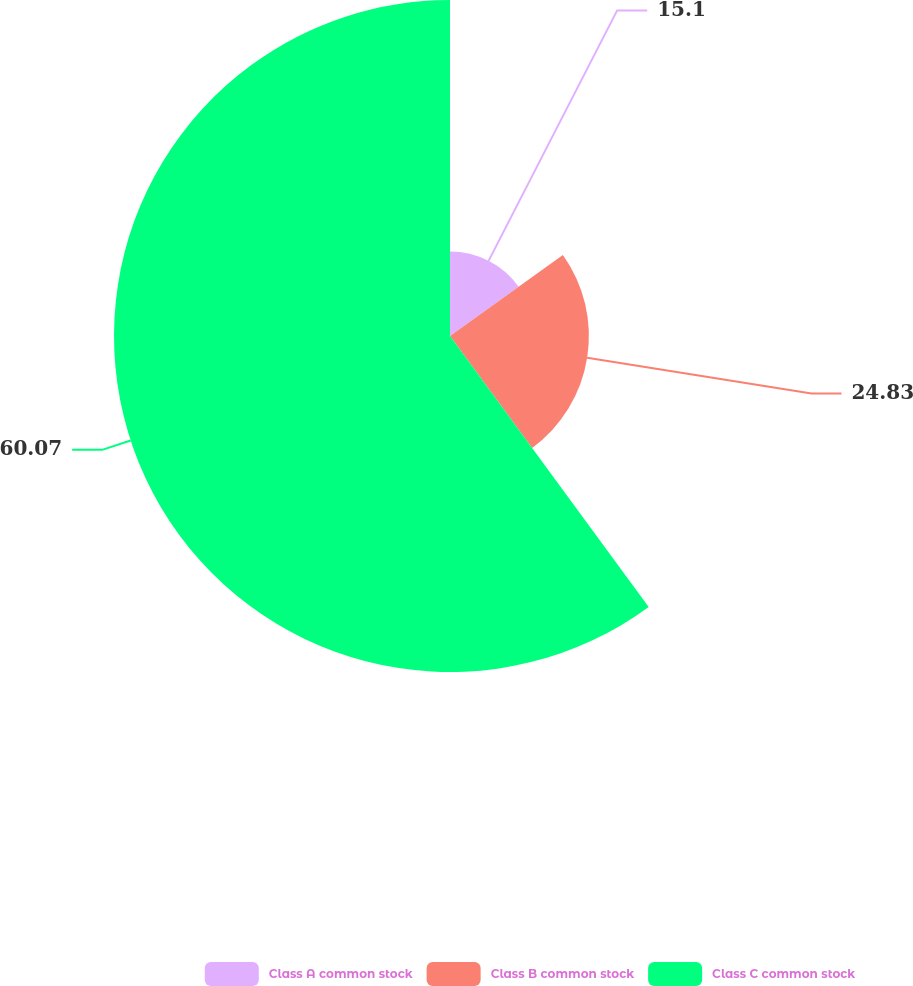Convert chart. <chart><loc_0><loc_0><loc_500><loc_500><pie_chart><fcel>Class A common stock<fcel>Class B common stock<fcel>Class C common stock<nl><fcel>15.1%<fcel>24.83%<fcel>60.07%<nl></chart> 